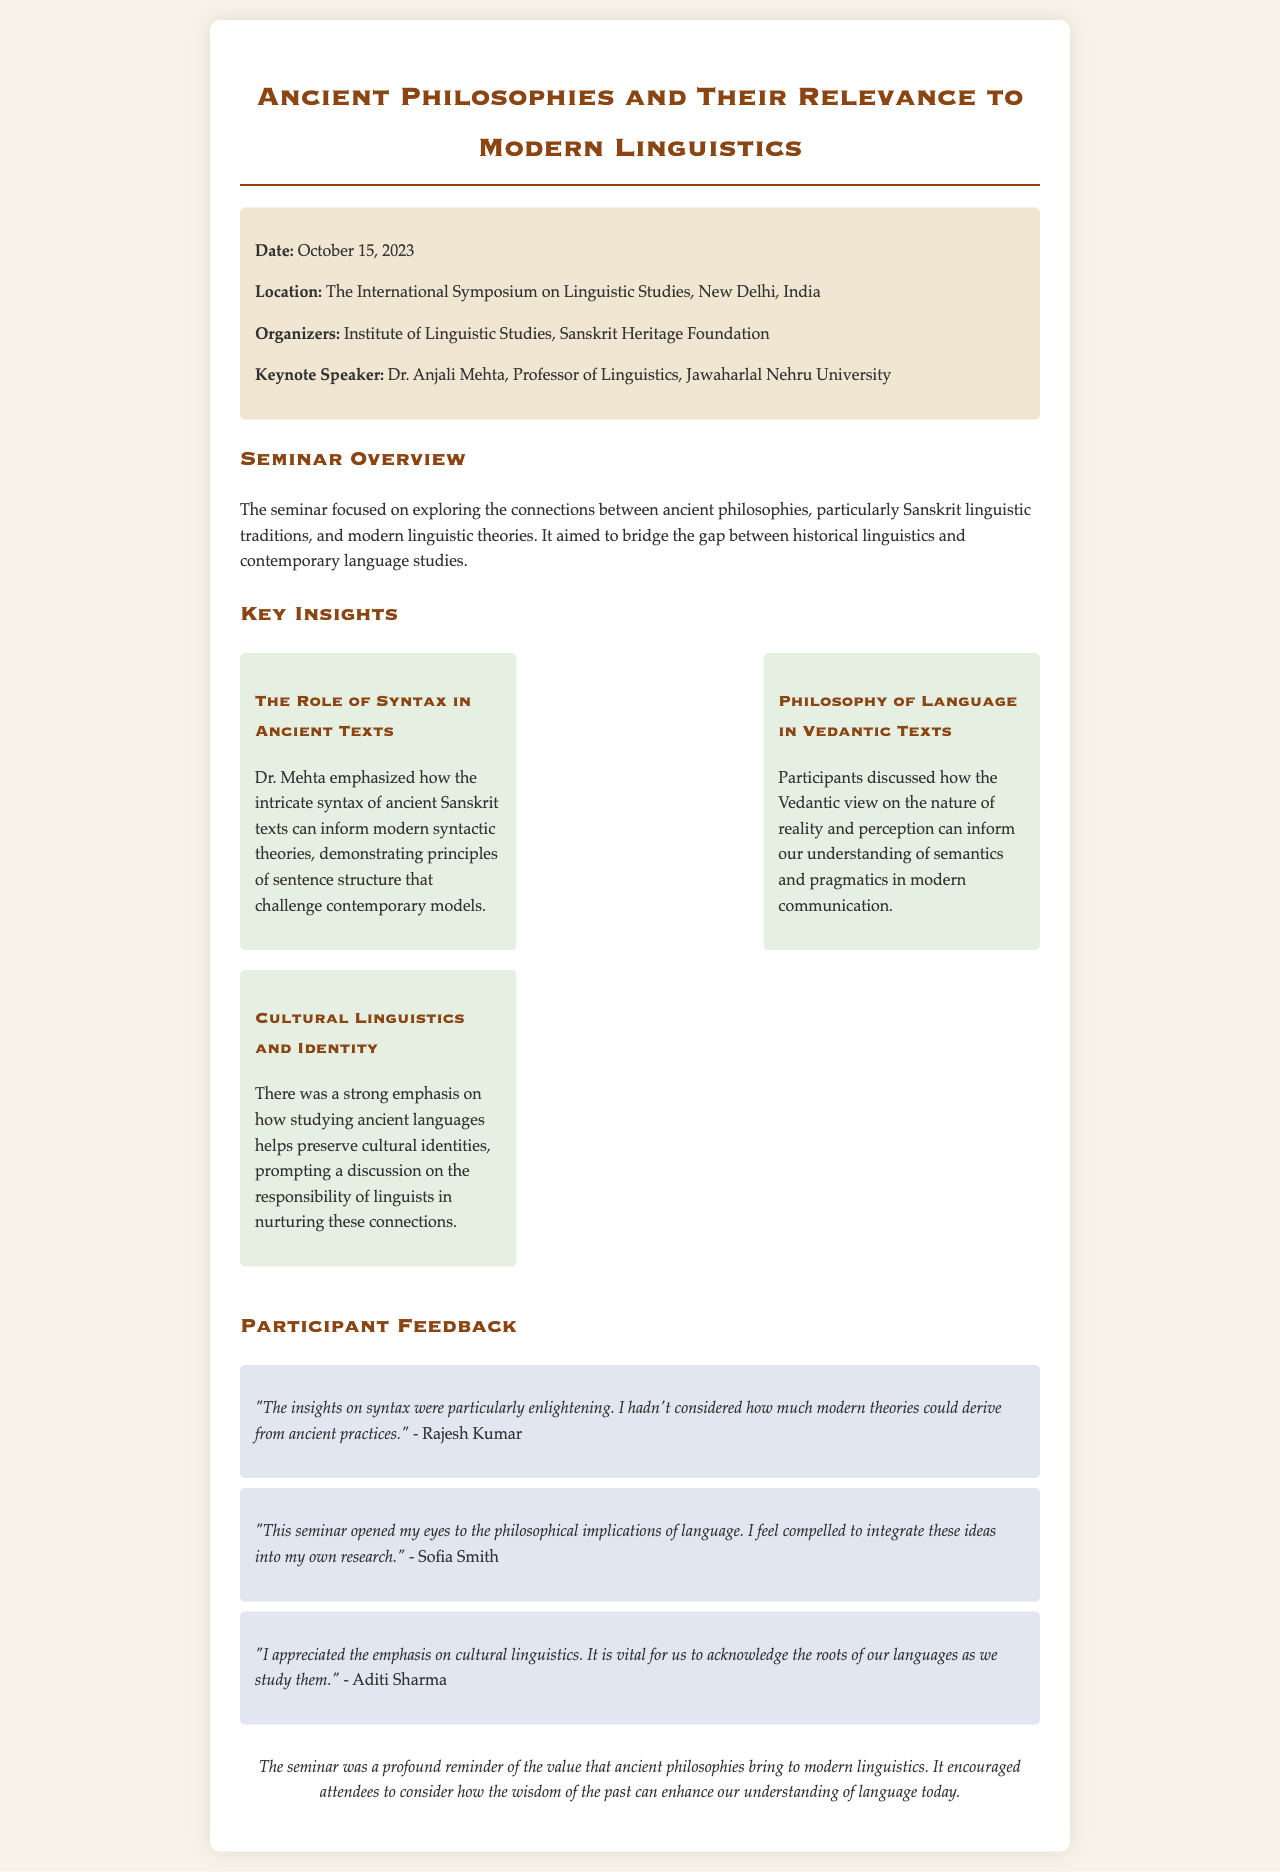What was the date of the seminar? The date of the seminar is explicitly stated in the document.
Answer: October 15, 2023 Who was the keynote speaker? The identity of the keynote speaker is provided in the seminar details section.
Answer: Dr. Anjali Mehta What is one of the main topics discussed regarding ancient texts? The document highlights key insights from Dr. Mehta's presentation regarding syntax.
Answer: The Role of Syntax in Ancient Texts Which organization organized the seminar? The seminar organizers are mentioned in the seminar details.
Answer: Institute of Linguistic Studies, Sanskrit Heritage Foundation What philosophical aspect was explored during the seminar? Participants discussed a specific perspective from ancient texts related to language philosophy.
Answer: Philosophy of Language in Vedantic Texts How did Rajesh Kumar describe the insights on syntax? Feedback from participants includes specific sentiments about the syntax insights shared during the seminar.
Answer: Enlightening What was emphasized about cultural linguistics? The document mentions a discussion about the importance of ancient languages in relation to identity.
Answer: Preserve cultural identities How did Sofia Smith feel after the seminar? Participant feedback provides insight into the emotional impact of the seminar on attendees.
Answer: Compelled to integrate these ideas into my own research What is noted as a conclusion of the seminar? The conclusion summarizes the overall takeaway from the seminar discussions.
Answer: Wisdom of the past can enhance our understanding of language today 